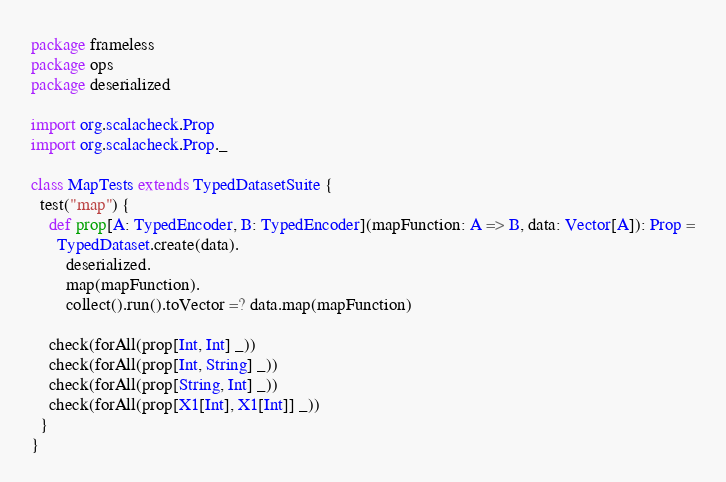Convert code to text. <code><loc_0><loc_0><loc_500><loc_500><_Scala_>package frameless
package ops
package deserialized

import org.scalacheck.Prop
import org.scalacheck.Prop._

class MapTests extends TypedDatasetSuite {
  test("map") {
    def prop[A: TypedEncoder, B: TypedEncoder](mapFunction: A => B, data: Vector[A]): Prop =
      TypedDataset.create(data).
        deserialized.
        map(mapFunction).
        collect().run().toVector =? data.map(mapFunction)

    check(forAll(prop[Int, Int] _))
    check(forAll(prop[Int, String] _))
    check(forAll(prop[String, Int] _))
    check(forAll(prop[X1[Int], X1[Int]] _))
  }
}
</code> 